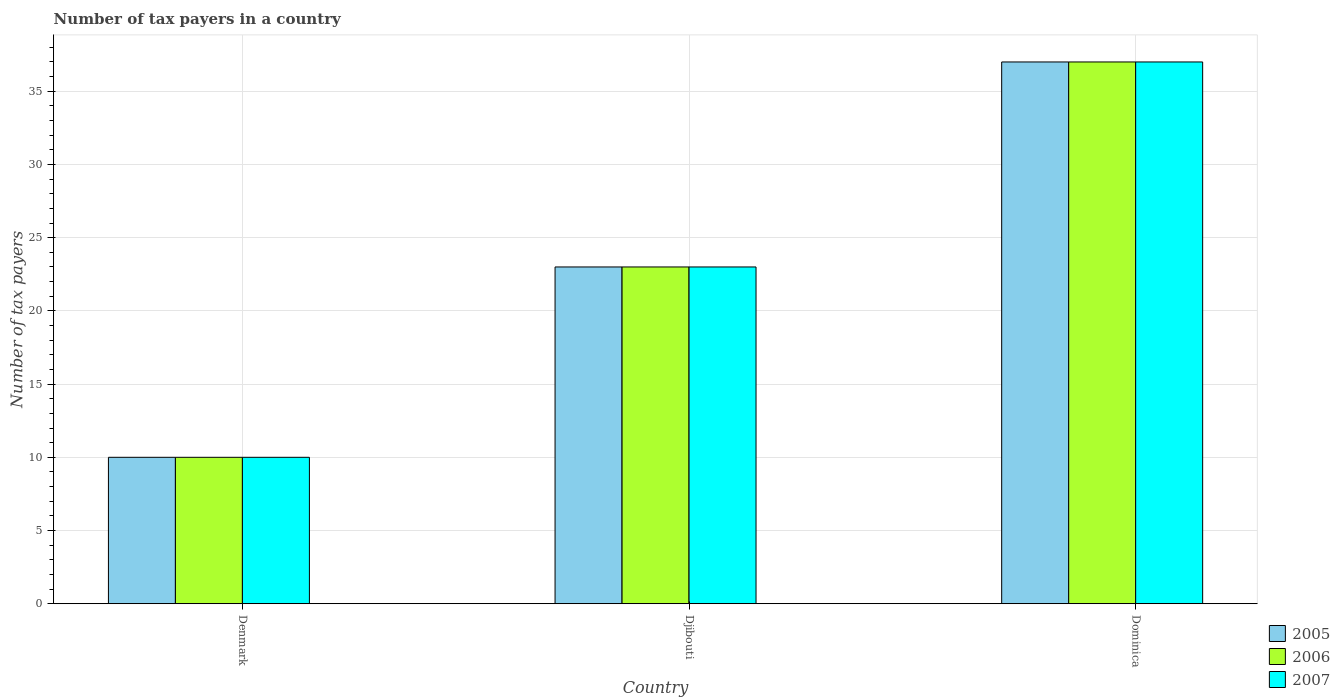How many different coloured bars are there?
Provide a succinct answer. 3. How many groups of bars are there?
Make the answer very short. 3. Are the number of bars per tick equal to the number of legend labels?
Give a very brief answer. Yes. How many bars are there on the 3rd tick from the left?
Give a very brief answer. 3. In which country was the number of tax payers in in 2007 maximum?
Provide a short and direct response. Dominica. What is the total number of tax payers in in 2005 in the graph?
Give a very brief answer. 70. What is the difference between the number of tax payers in in 2005 in Djibouti and that in Dominica?
Your response must be concise. -14. What is the average number of tax payers in in 2007 per country?
Your answer should be compact. 23.33. What is the difference between the number of tax payers in of/in 2006 and number of tax payers in of/in 2007 in Dominica?
Offer a terse response. 0. What is the ratio of the number of tax payers in in 2006 in Djibouti to that in Dominica?
Provide a short and direct response. 0.62. Is the number of tax payers in in 2006 in Denmark less than that in Dominica?
Give a very brief answer. Yes. What is the difference between the highest and the lowest number of tax payers in in 2007?
Keep it short and to the point. 27. What does the 2nd bar from the left in Djibouti represents?
Offer a very short reply. 2006. How many bars are there?
Ensure brevity in your answer.  9. Are all the bars in the graph horizontal?
Provide a succinct answer. No. How many countries are there in the graph?
Make the answer very short. 3. What is the difference between two consecutive major ticks on the Y-axis?
Keep it short and to the point. 5. Does the graph contain grids?
Ensure brevity in your answer.  Yes. How many legend labels are there?
Give a very brief answer. 3. How are the legend labels stacked?
Your answer should be very brief. Vertical. What is the title of the graph?
Offer a very short reply. Number of tax payers in a country. What is the label or title of the X-axis?
Offer a very short reply. Country. What is the label or title of the Y-axis?
Your answer should be compact. Number of tax payers. What is the Number of tax payers in 2005 in Djibouti?
Give a very brief answer. 23. What is the Number of tax payers in 2007 in Djibouti?
Keep it short and to the point. 23. What is the Number of tax payers of 2005 in Dominica?
Keep it short and to the point. 37. What is the Number of tax payers in 2006 in Dominica?
Your answer should be compact. 37. What is the Number of tax payers in 2007 in Dominica?
Your answer should be very brief. 37. Across all countries, what is the maximum Number of tax payers of 2007?
Make the answer very short. 37. Across all countries, what is the minimum Number of tax payers in 2007?
Ensure brevity in your answer.  10. What is the total Number of tax payers in 2005 in the graph?
Your answer should be very brief. 70. What is the total Number of tax payers of 2006 in the graph?
Your response must be concise. 70. What is the difference between the Number of tax payers of 2005 in Denmark and that in Djibouti?
Your answer should be compact. -13. What is the difference between the Number of tax payers of 2006 in Denmark and that in Djibouti?
Offer a very short reply. -13. What is the difference between the Number of tax payers of 2006 in Denmark and that in Dominica?
Ensure brevity in your answer.  -27. What is the difference between the Number of tax payers in 2007 in Denmark and that in Dominica?
Ensure brevity in your answer.  -27. What is the difference between the Number of tax payers in 2005 in Djibouti and that in Dominica?
Keep it short and to the point. -14. What is the difference between the Number of tax payers of 2005 in Denmark and the Number of tax payers of 2007 in Djibouti?
Your answer should be very brief. -13. What is the difference between the Number of tax payers of 2006 in Denmark and the Number of tax payers of 2007 in Dominica?
Provide a succinct answer. -27. What is the difference between the Number of tax payers of 2006 in Djibouti and the Number of tax payers of 2007 in Dominica?
Make the answer very short. -14. What is the average Number of tax payers of 2005 per country?
Offer a terse response. 23.33. What is the average Number of tax payers of 2006 per country?
Offer a very short reply. 23.33. What is the average Number of tax payers of 2007 per country?
Keep it short and to the point. 23.33. What is the difference between the Number of tax payers of 2006 and Number of tax payers of 2007 in Denmark?
Provide a succinct answer. 0. What is the difference between the Number of tax payers in 2005 and Number of tax payers in 2006 in Djibouti?
Keep it short and to the point. 0. What is the difference between the Number of tax payers in 2006 and Number of tax payers in 2007 in Djibouti?
Provide a succinct answer. 0. What is the difference between the Number of tax payers of 2005 and Number of tax payers of 2007 in Dominica?
Your answer should be very brief. 0. What is the ratio of the Number of tax payers of 2005 in Denmark to that in Djibouti?
Provide a succinct answer. 0.43. What is the ratio of the Number of tax payers in 2006 in Denmark to that in Djibouti?
Provide a succinct answer. 0.43. What is the ratio of the Number of tax payers of 2007 in Denmark to that in Djibouti?
Provide a short and direct response. 0.43. What is the ratio of the Number of tax payers in 2005 in Denmark to that in Dominica?
Give a very brief answer. 0.27. What is the ratio of the Number of tax payers of 2006 in Denmark to that in Dominica?
Your answer should be very brief. 0.27. What is the ratio of the Number of tax payers in 2007 in Denmark to that in Dominica?
Provide a succinct answer. 0.27. What is the ratio of the Number of tax payers in 2005 in Djibouti to that in Dominica?
Your answer should be compact. 0.62. What is the ratio of the Number of tax payers of 2006 in Djibouti to that in Dominica?
Make the answer very short. 0.62. What is the ratio of the Number of tax payers in 2007 in Djibouti to that in Dominica?
Keep it short and to the point. 0.62. What is the difference between the highest and the second highest Number of tax payers in 2006?
Your answer should be very brief. 14. What is the difference between the highest and the lowest Number of tax payers of 2005?
Ensure brevity in your answer.  27. 